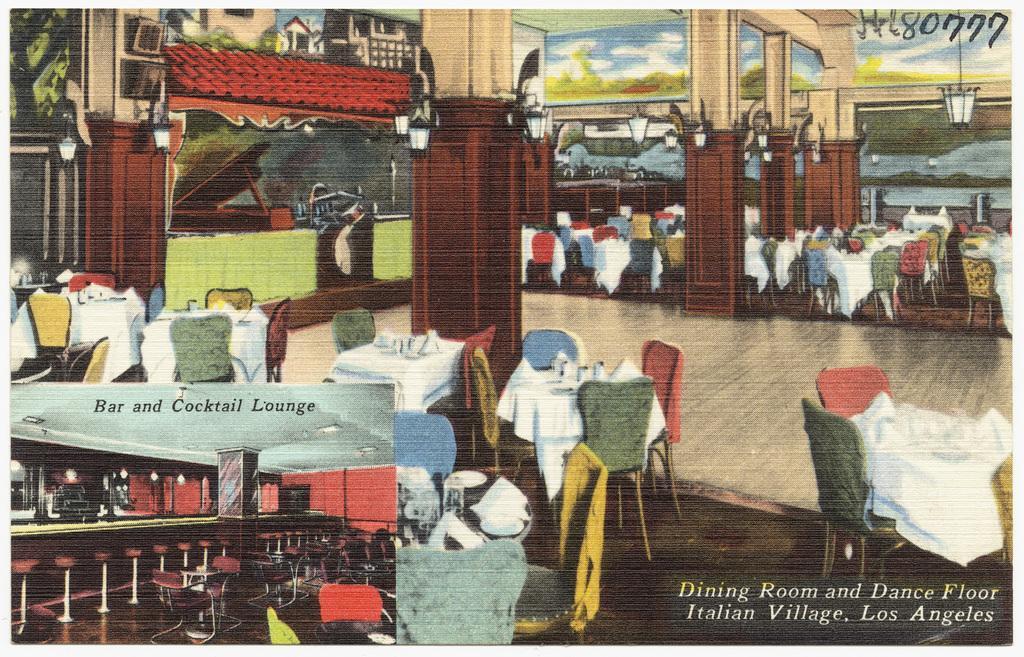Describe this image in one or two sentences. This is a poster, in this image there are some pillars, tables, chairs, and on the tables there are clothes, glasses and some objects. And on the left side of the image there is bar, chairs, pillars, ceiling, lights and floor. And in the background there is a wall, and on the wall there is art and also we could see some lights, televisions and some other objects. At the bottom there is floor, and there is text. 